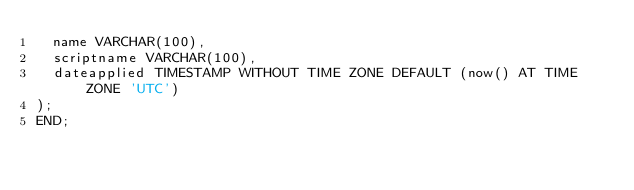<code> <loc_0><loc_0><loc_500><loc_500><_SQL_>  name VARCHAR(100),
  scriptname VARCHAR(100),
  dateapplied TIMESTAMP WITHOUT TIME ZONE DEFAULT (now() AT TIME ZONE 'UTC')
);
END;</code> 